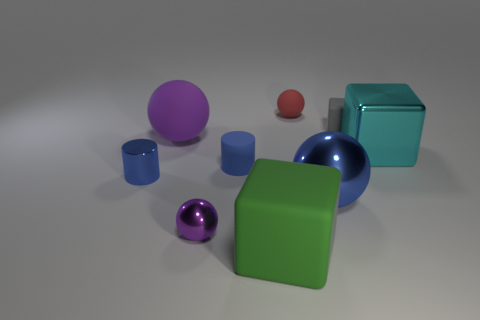How many gray objects are tiny rubber cubes or big matte blocks?
Offer a very short reply. 1. There is another cylinder that is the same color as the small rubber cylinder; what is its size?
Keep it short and to the point. Small. Are there more tiny blue cylinders than cyan blocks?
Provide a short and direct response. Yes. Is the color of the metal cylinder the same as the big shiny ball?
Your answer should be compact. Yes. What number of objects are either gray rubber cubes or small matte things that are on the right side of the tiny red rubber thing?
Offer a very short reply. 1. How many other things are there of the same shape as the small blue matte thing?
Ensure brevity in your answer.  1. Are there fewer small red things to the left of the cyan object than gray matte objects that are in front of the purple matte object?
Make the answer very short. No. What shape is the cyan thing that is made of the same material as the tiny purple thing?
Offer a very short reply. Cube. Are there any other things that are the same color as the small metal ball?
Your answer should be compact. Yes. There is a small sphere that is on the left side of the red rubber thing that is to the left of the shiny block; what is its color?
Your answer should be compact. Purple. 